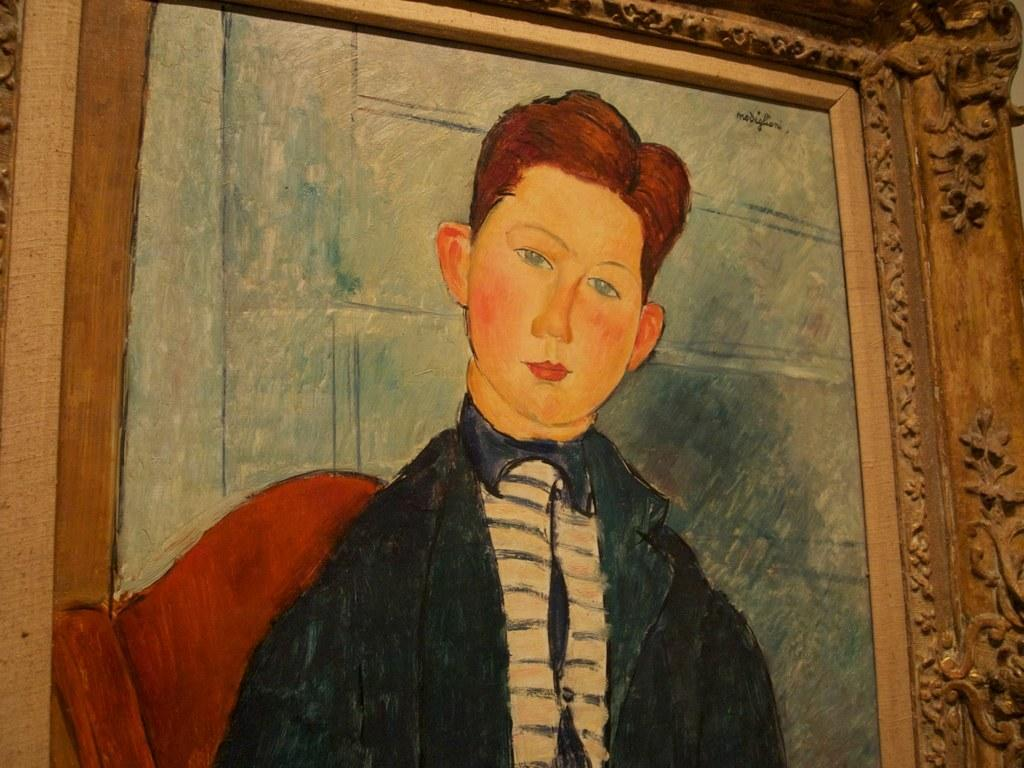What object is present in the image that typically holds a picture or artwork? There is a photo frame in the image. What type of artwork is displayed within the photo frame? The photo frame contains a painting of a person. What type of corn can be seen growing in the photo frame? There is no corn present in the image; the photo frame contains a painting of a person. 